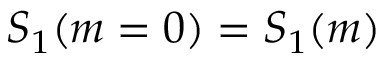<formula> <loc_0><loc_0><loc_500><loc_500>S _ { 1 } ( m = 0 ) = S _ { 1 } ( m )</formula> 